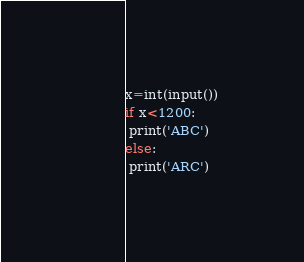<code> <loc_0><loc_0><loc_500><loc_500><_Python_>x=int(input())
if x<1200:
 print('ABC')
else:
 print('ARC')</code> 